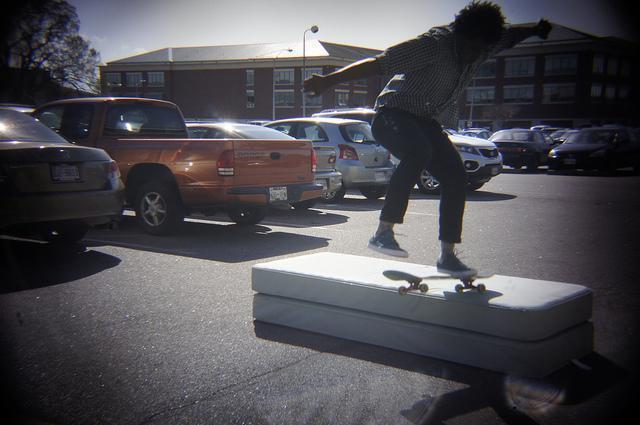How many cars are in the picture?
Give a very brief answer. 6. How many vans follows the bus in a given image?
Give a very brief answer. 0. 